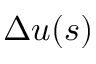<formula> <loc_0><loc_0><loc_500><loc_500>\Delta u ( s )</formula> 